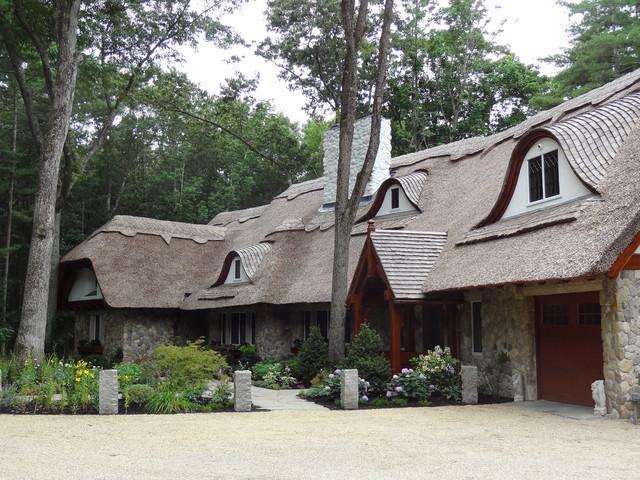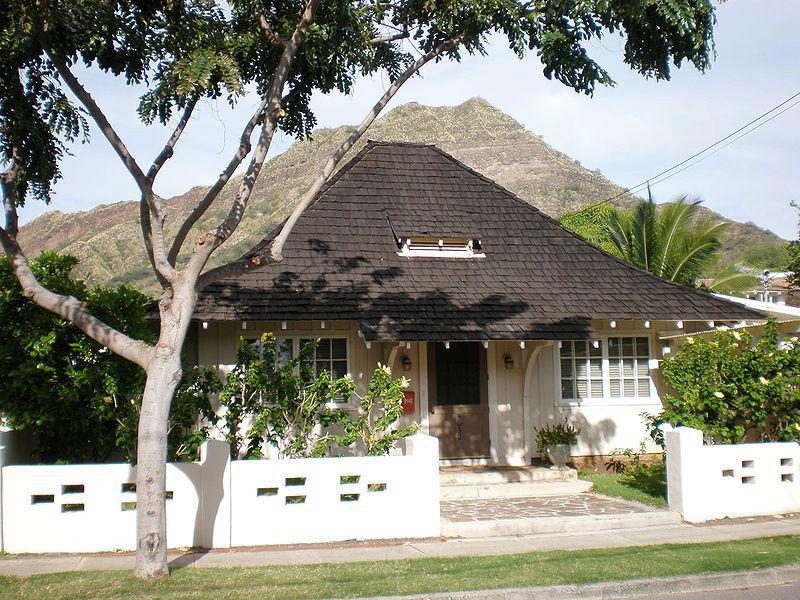The first image is the image on the left, the second image is the image on the right. For the images shown, is this caption "The right image shows a house with windows featuring different shaped panes below a thick gray roof with a rounded section in front and a scalloped border on the peak edge." true? Answer yes or no. No. 